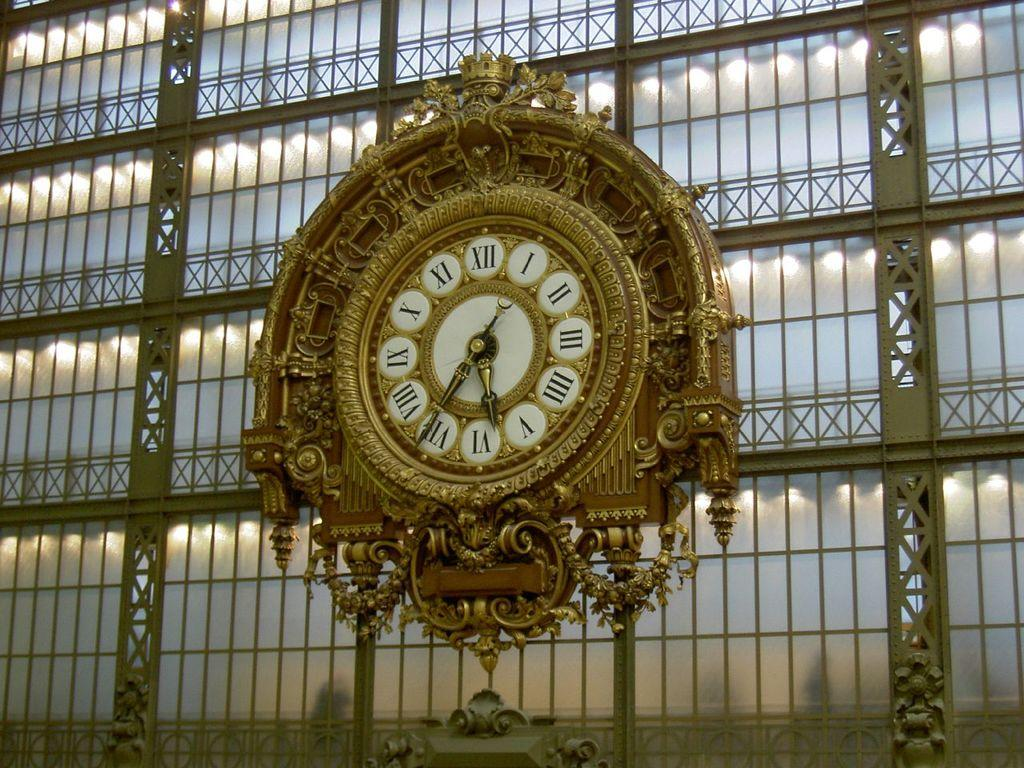What type of structure is visible in the image? There is a building in the image. Are there any specific features on the building? Yes, there is a clock on the building. Is there anything else on the building besides the clock? Yes, there is an unspecified object on the building. How many snails can be seen crawling on the building in the image? There are no snails visible on the building in the image. What phase of the moon is depicted in the image? The image does not show the moon, so it is not possible to determine its phase. 